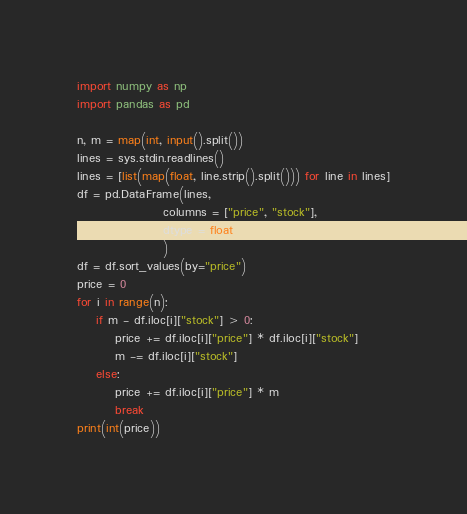<code> <loc_0><loc_0><loc_500><loc_500><_Python_>import numpy as np
import pandas as pd

n, m = map(int, input().split())
lines = sys.stdin.readlines()
lines = [list(map(float, line.strip().split())) for line in lines]
df = pd.DataFrame(lines,
                  columns = ["price", "stock"],
                  dtype = float
                  )
df = df.sort_values(by="price")
price = 0
for i in range(n):
    if m - df.iloc[i]["stock"] > 0:
        price += df.iloc[i]["price"] * df.iloc[i]["stock"]
        m -= df.iloc[i]["stock"]
    else:
        price += df.iloc[i]["price"] * m
        break
print(int(price))</code> 